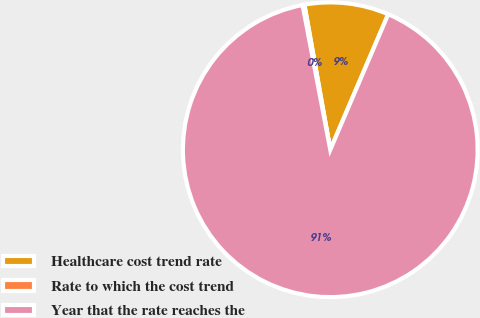Convert chart. <chart><loc_0><loc_0><loc_500><loc_500><pie_chart><fcel>Healthcare cost trend rate<fcel>Rate to which the cost trend<fcel>Year that the rate reaches the<nl><fcel>9.24%<fcel>0.2%<fcel>90.56%<nl></chart> 